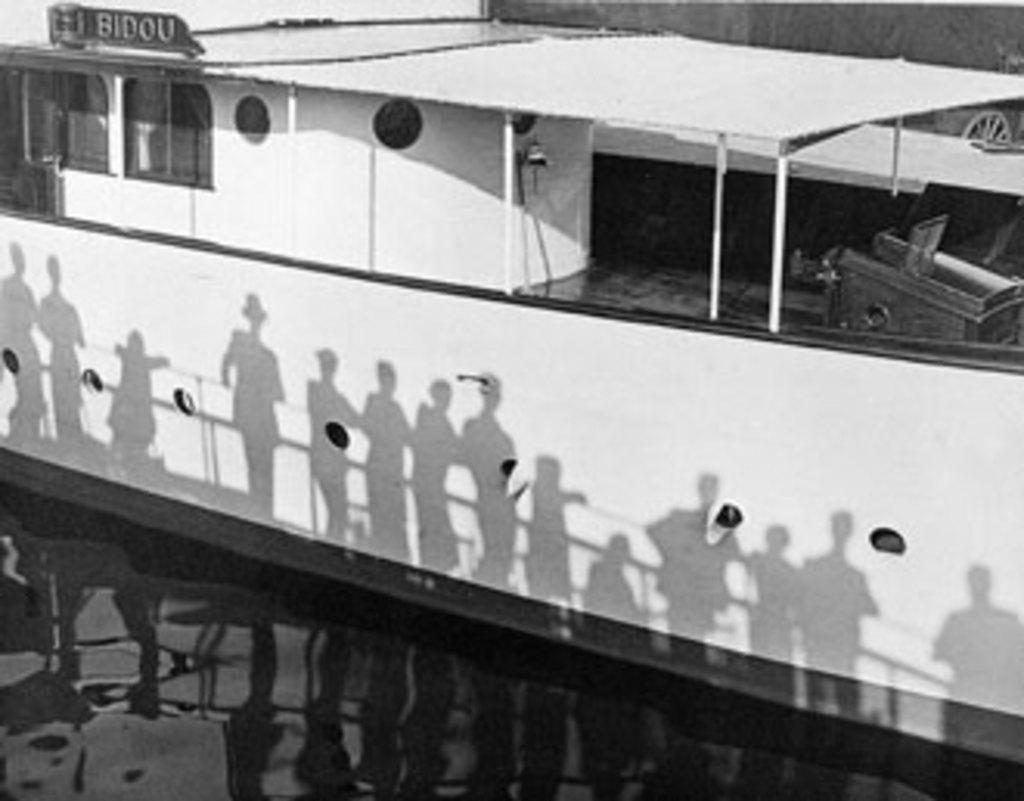<image>
Offer a succinct explanation of the picture presented. the word Bidou at the top of a bvoat 